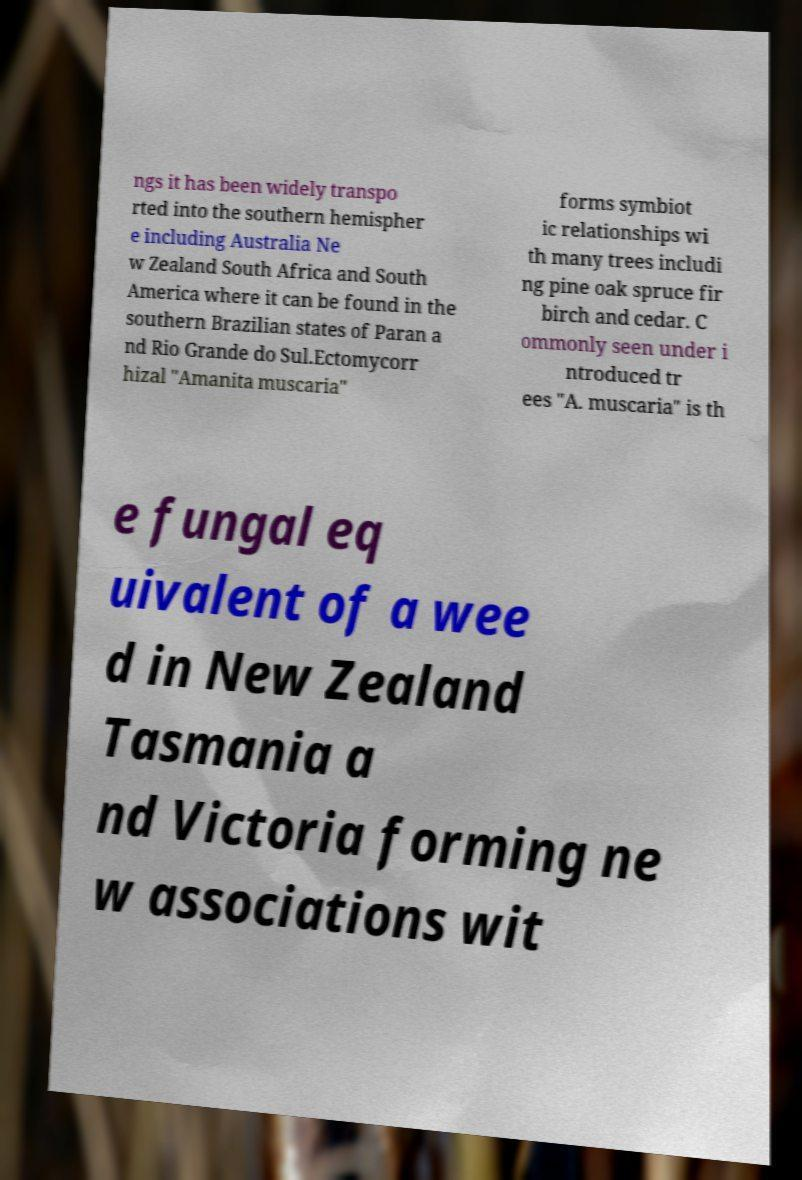Please identify and transcribe the text found in this image. ngs it has been widely transpo rted into the southern hemispher e including Australia Ne w Zealand South Africa and South America where it can be found in the southern Brazilian states of Paran a nd Rio Grande do Sul.Ectomycorr hizal "Amanita muscaria" forms symbiot ic relationships wi th many trees includi ng pine oak spruce fir birch and cedar. C ommonly seen under i ntroduced tr ees "A. muscaria" is th e fungal eq uivalent of a wee d in New Zealand Tasmania a nd Victoria forming ne w associations wit 